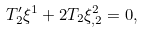Convert formula to latex. <formula><loc_0><loc_0><loc_500><loc_500>T ^ { \prime } _ { 2 } \xi ^ { 1 } + 2 T _ { 2 } \xi ^ { 2 } _ { , 2 } = 0 ,</formula> 